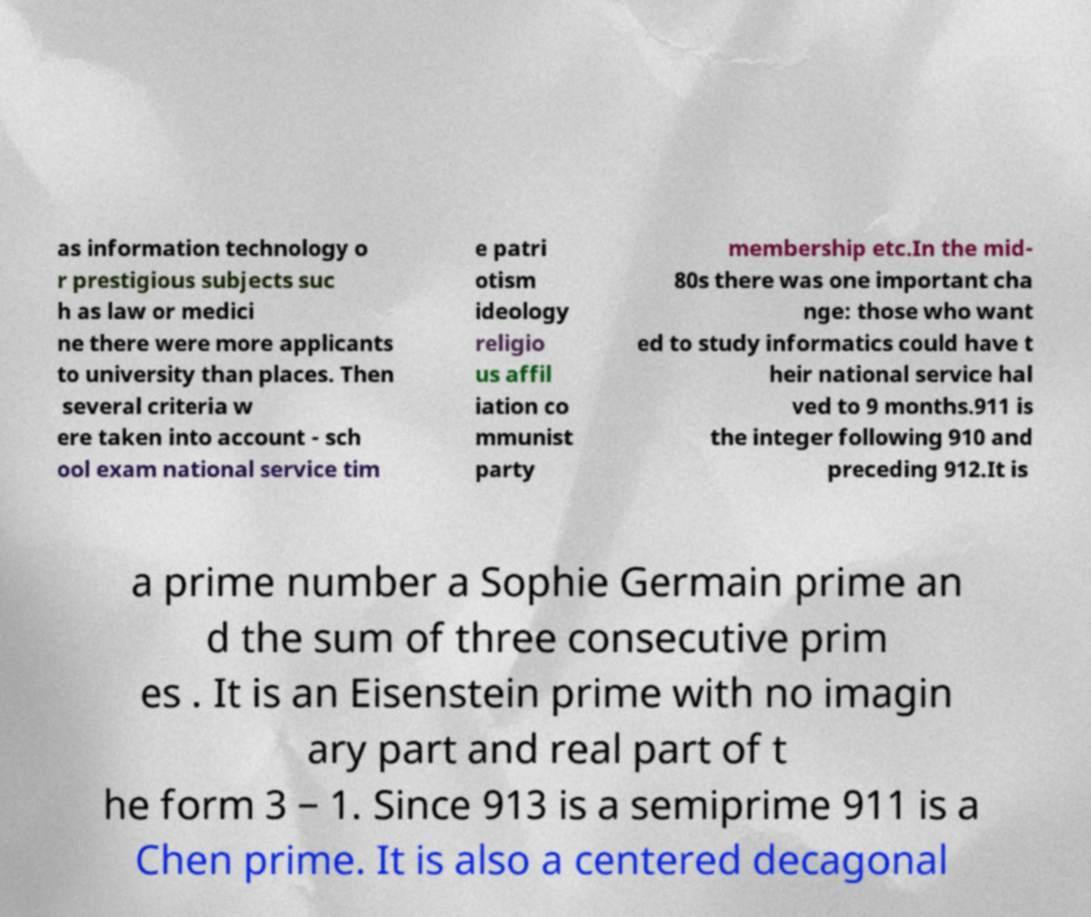Please read and relay the text visible in this image. What does it say? as information technology o r prestigious subjects suc h as law or medici ne there were more applicants to university than places. Then several criteria w ere taken into account - sch ool exam national service tim e patri otism ideology religio us affil iation co mmunist party membership etc.In the mid- 80s there was one important cha nge: those who want ed to study informatics could have t heir national service hal ved to 9 months.911 is the integer following 910 and preceding 912.It is a prime number a Sophie Germain prime an d the sum of three consecutive prim es . It is an Eisenstein prime with no imagin ary part and real part of t he form 3 − 1. Since 913 is a semiprime 911 is a Chen prime. It is also a centered decagonal 